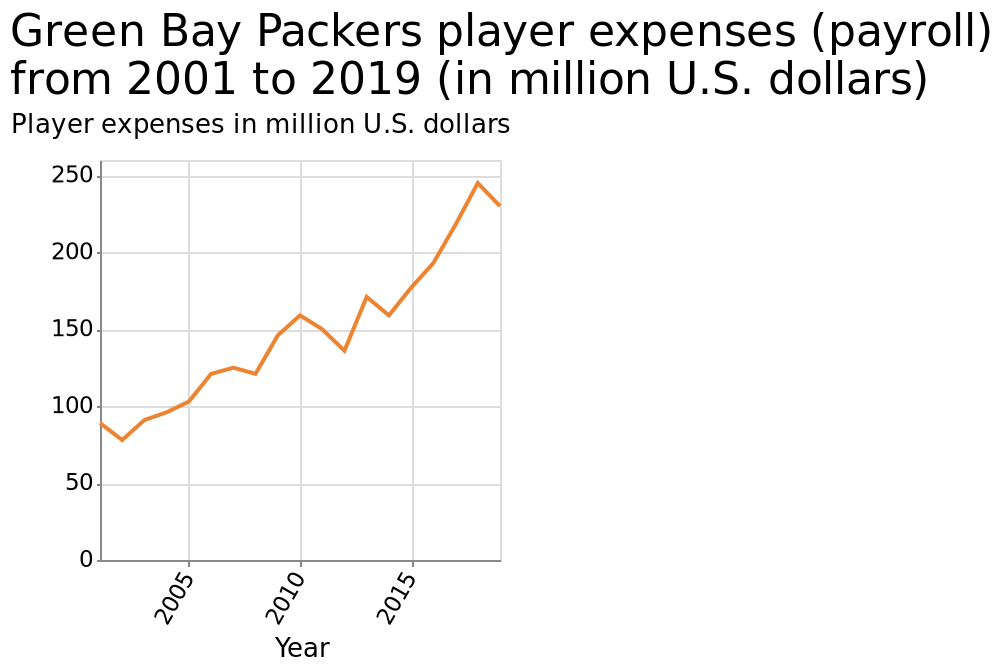<image>
What does the x-axis represent on the line graph?  The x-axis represents the years from 2001 to 2019. 